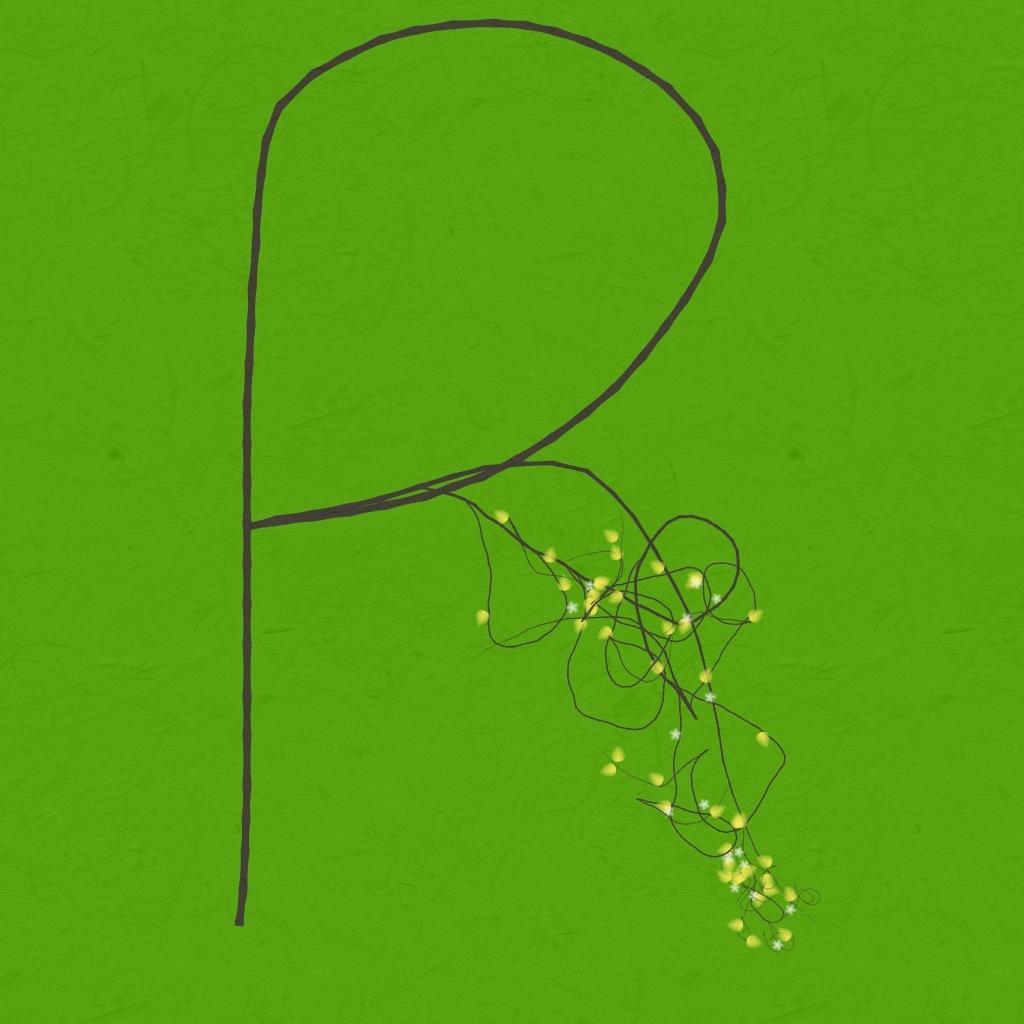Describe this image in one or two sentences. In this picture there is a green paper and which small craft drawing is done with the black sketch. 